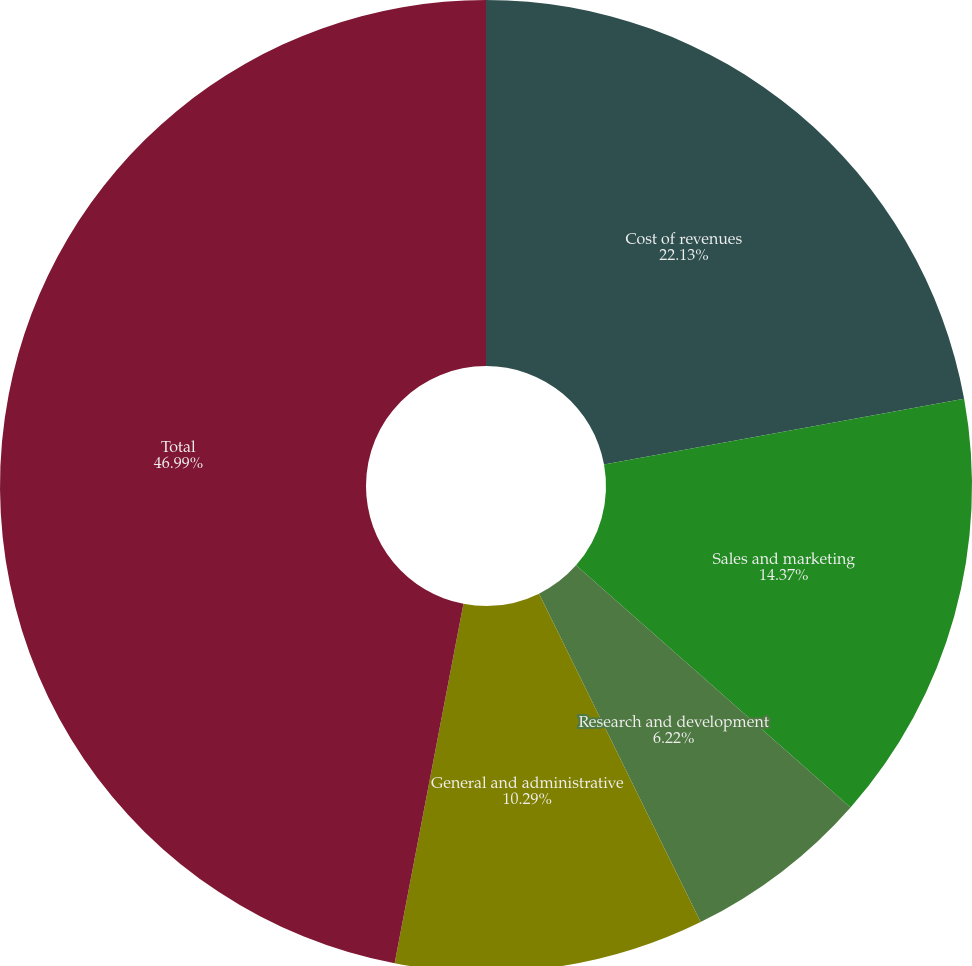<chart> <loc_0><loc_0><loc_500><loc_500><pie_chart><fcel>Cost of revenues<fcel>Sales and marketing<fcel>Research and development<fcel>General and administrative<fcel>Total<nl><fcel>22.13%<fcel>14.37%<fcel>6.22%<fcel>10.29%<fcel>46.99%<nl></chart> 